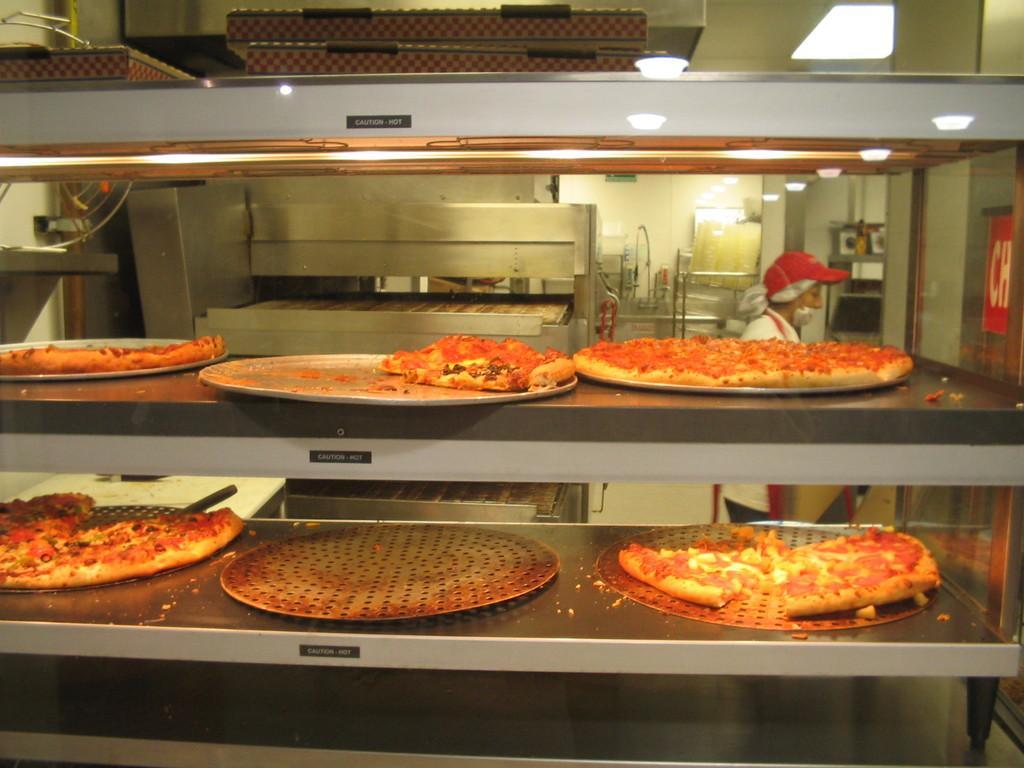Please provide a concise description of this image. In the foreground of the picture we can see pizzas in a microwave oven. In the middle of the picture there are some kitchen utensils, a person and various other objects. In the background we can see wall and various kitchen utensils. 